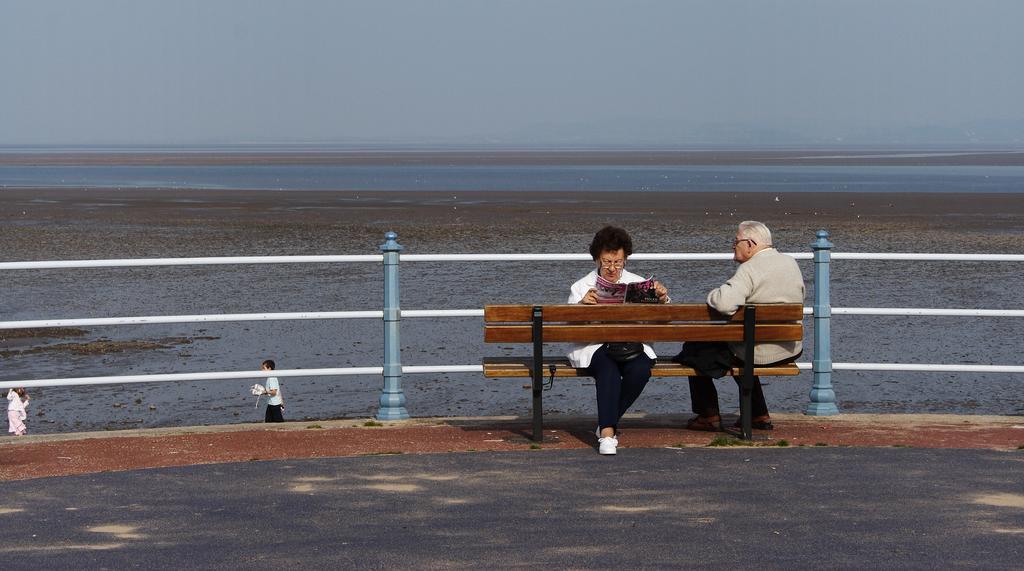How would you summarize this image in a sentence or two? This picture shows a woman and a man seated on the bench and a woman reading a magazine and we see few water in the lake and a metal fence and we see two people walking 